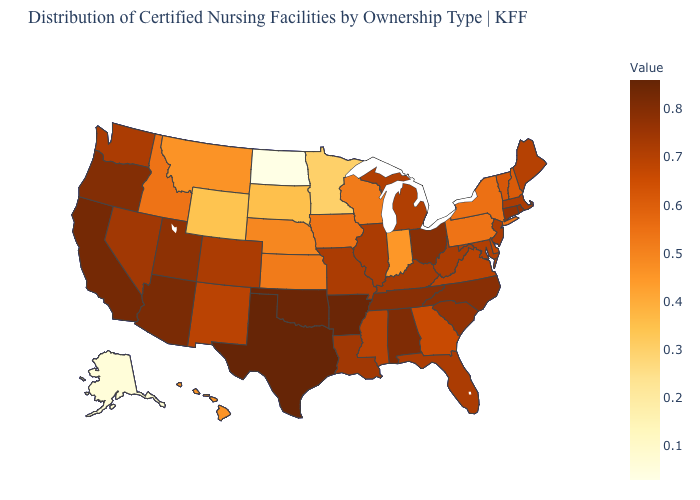Among the states that border New Mexico , which have the highest value?
Write a very short answer. Texas. Among the states that border Massachusetts , does Rhode Island have the lowest value?
Quick response, please. No. Among the states that border New Mexico , does Colorado have the lowest value?
Be succinct. Yes. Does Ohio have the highest value in the MidWest?
Keep it brief. Yes. Among the states that border North Dakota , which have the highest value?
Be succinct. Montana. Which states have the lowest value in the USA?
Concise answer only. North Dakota. 